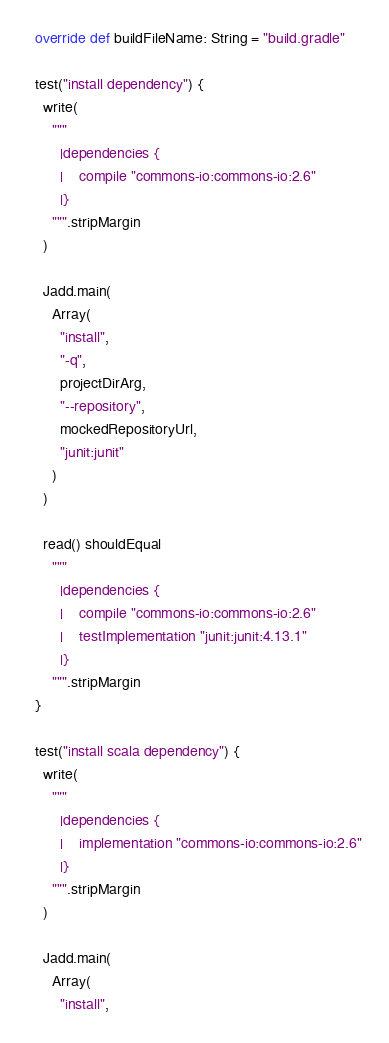<code> <loc_0><loc_0><loc_500><loc_500><_Scala_>
  override def buildFileName: String = "build.gradle"

  test("install dependency") {
    write(
      """
        |dependencies {
        |    compile "commons-io:commons-io:2.6"
        |}
      """.stripMargin
    )

    Jadd.main(
      Array(
        "install",
        "-q",
        projectDirArg,
        "--repository",
        mockedRepositoryUrl,
        "junit:junit"
      )
    )

    read() shouldEqual
      """
        |dependencies {
        |    compile "commons-io:commons-io:2.6"
        |    testImplementation "junit:junit:4.13.1"
        |}
      """.stripMargin
  }

  test("install scala dependency") {
    write(
      """
        |dependencies {
        |    implementation "commons-io:commons-io:2.6"
        |}
      """.stripMargin
    )

    Jadd.main(
      Array(
        "install",</code> 